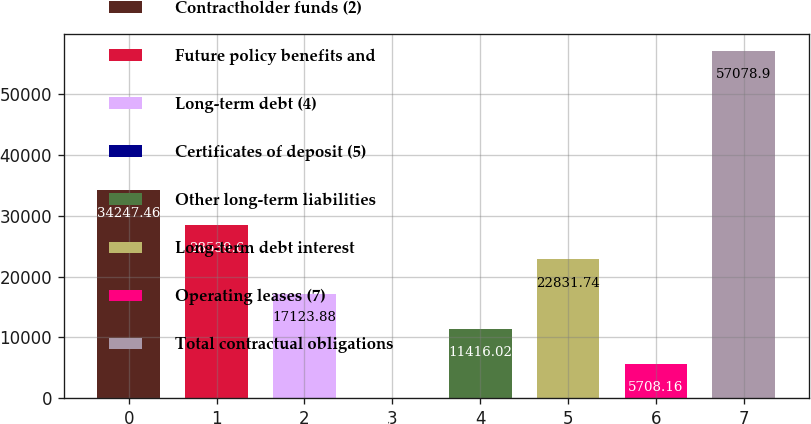Convert chart. <chart><loc_0><loc_0><loc_500><loc_500><bar_chart><fcel>Contractholder funds (2)<fcel>Future policy benefits and<fcel>Long-term debt (4)<fcel>Certificates of deposit (5)<fcel>Other long-term liabilities<fcel>Long-term debt interest<fcel>Operating leases (7)<fcel>Total contractual obligations<nl><fcel>34247.5<fcel>28539.6<fcel>17123.9<fcel>0.3<fcel>11416<fcel>22831.7<fcel>5708.16<fcel>57078.9<nl></chart> 